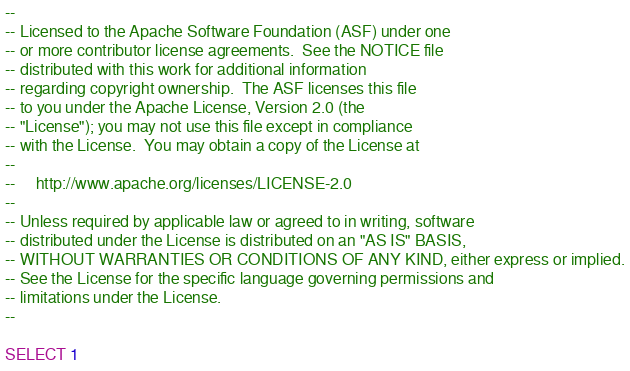Convert code to text. <code><loc_0><loc_0><loc_500><loc_500><_SQL_>--
-- Licensed to the Apache Software Foundation (ASF) under one
-- or more contributor license agreements.  See the NOTICE file
-- distributed with this work for additional information
-- regarding copyright ownership.  The ASF licenses this file
-- to you under the Apache License, Version 2.0 (the
-- "License"); you may not use this file except in compliance
-- with the License.  You may obtain a copy of the License at
--
--     http://www.apache.org/licenses/LICENSE-2.0
--
-- Unless required by applicable law or agreed to in writing, software
-- distributed under the License is distributed on an "AS IS" BASIS,
-- WITHOUT WARRANTIES OR CONDITIONS OF ANY KIND, either express or implied.
-- See the License for the specific language governing permissions and
-- limitations under the License.
--

SELECT 1 
</code> 